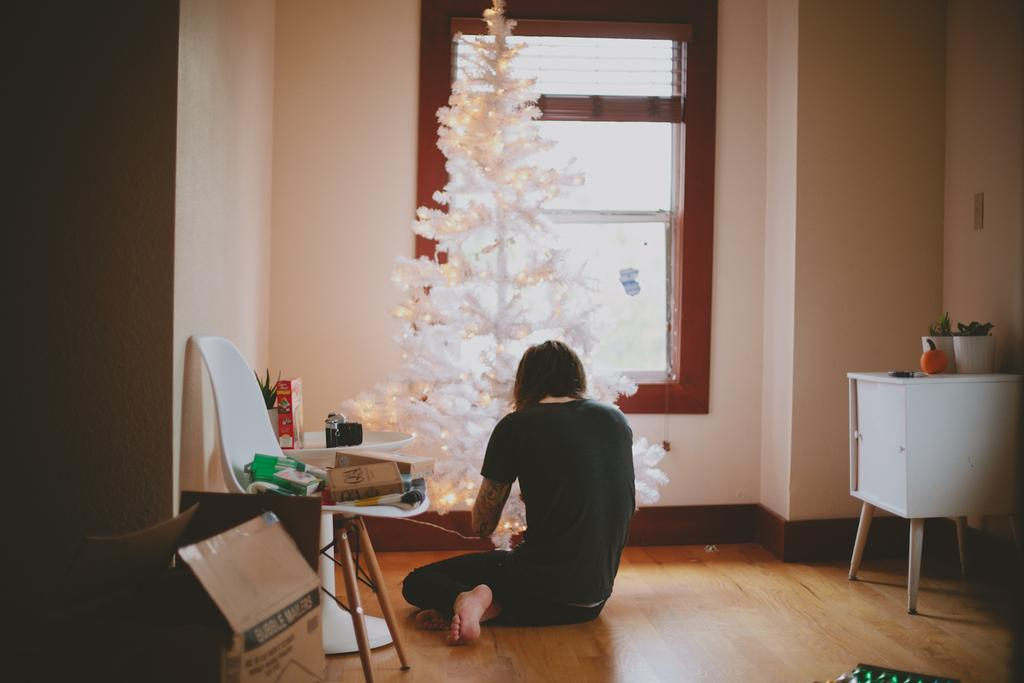What is the person in the image doing? The person is sitting on the floor in the image. What seasonal decoration can be seen in the image? There is a Christmas tree in the image. What type of furniture is present in the image? There are chairs in the image. What objects are in the image that might contain gifts or other items? There are boxes in the image. How many screws are visible on the person's clothing in the image? There are no screws visible on the person's clothing in the image. 